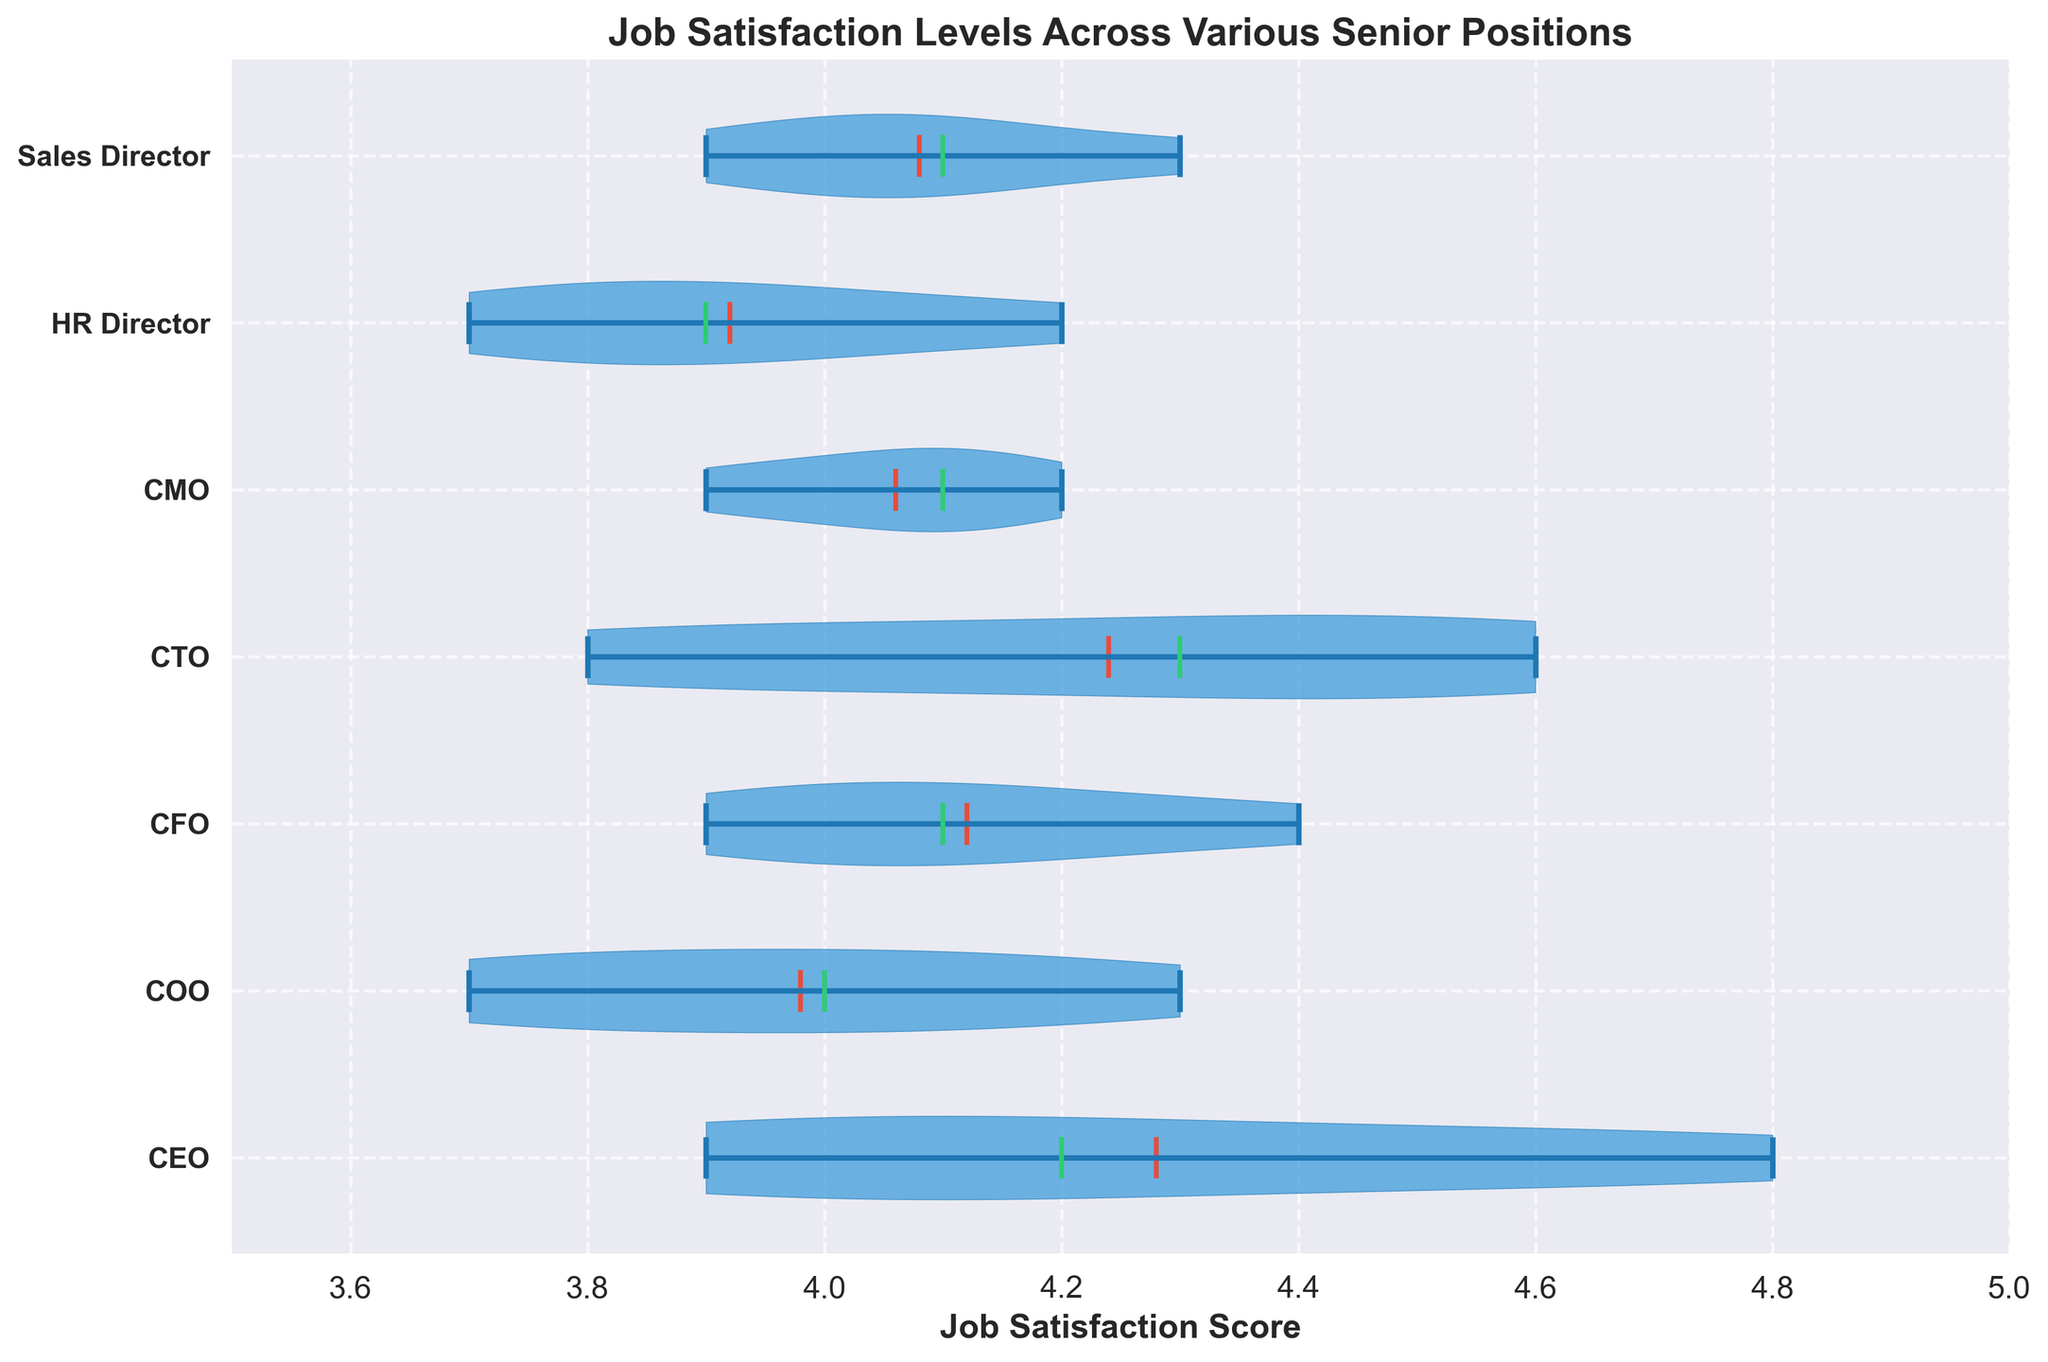What is the title of the figure? The title of the figure is written at the top of the plot.
Answer: Job Satisfaction Levels Across Various Senior Positions Which senior position has the broadest distribution of job satisfaction? The broadest distribution will show the widest spread or the most extended 'violin' shape.
Answer: HR Director What is the median job satisfaction score for the CTO position? The median score is represented by the green line within the violin plot for CTO.
Answer: 4.3 How does the mean job satisfaction score for the CEO compare to the mean for the COO? The mean job satisfaction score is indicated by the red line within each violin plot. Comparing their positions will determine which is higher or lower.
Answer: The mean for CEO is higher than COO Which position has the highest mean job satisfaction score? The highest mean score is indicated by the position of the red line within the violin plots among all positions.
Answer: CTO Is the job satisfaction variance higher for the CMO or the Sales Director? Variance is illustrated by the spread of the violin plot, with a wider spread indicating higher variance. By comparing the spreads, we can determine which is greater.
Answer: Sales Director What is the minimum job satisfaction score for the HR Director position? The minimum score is observed at the lowest point of the violin plot for the HR Director position.
Answer: 3.7 Compare the middle 50% range (interquartile range) of job satisfaction scores between the CFO and CTO positions. The IQR is the range between the first and third quartiles, represented by the spread within the central part of the violin plot (excluding the tails). Observing their relative span will indicate which is wider or narrower.
Answer: CTO has a wider IQR than CFO Which senior position has the smallest range of job satisfaction scores? The smallest range will show the least spread between the minimum and maximum within the violin plot.
Answer: COO What's the highest recorded job satisfaction score across all senior positions? By examining the violin plots, identify the highest point reached within any individual plot.
Answer: 4.8 